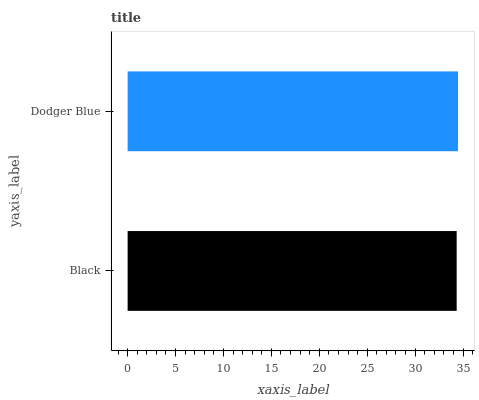Is Black the minimum?
Answer yes or no. Yes. Is Dodger Blue the maximum?
Answer yes or no. Yes. Is Dodger Blue the minimum?
Answer yes or no. No. Is Dodger Blue greater than Black?
Answer yes or no. Yes. Is Black less than Dodger Blue?
Answer yes or no. Yes. Is Black greater than Dodger Blue?
Answer yes or no. No. Is Dodger Blue less than Black?
Answer yes or no. No. Is Dodger Blue the high median?
Answer yes or no. Yes. Is Black the low median?
Answer yes or no. Yes. Is Black the high median?
Answer yes or no. No. Is Dodger Blue the low median?
Answer yes or no. No. 